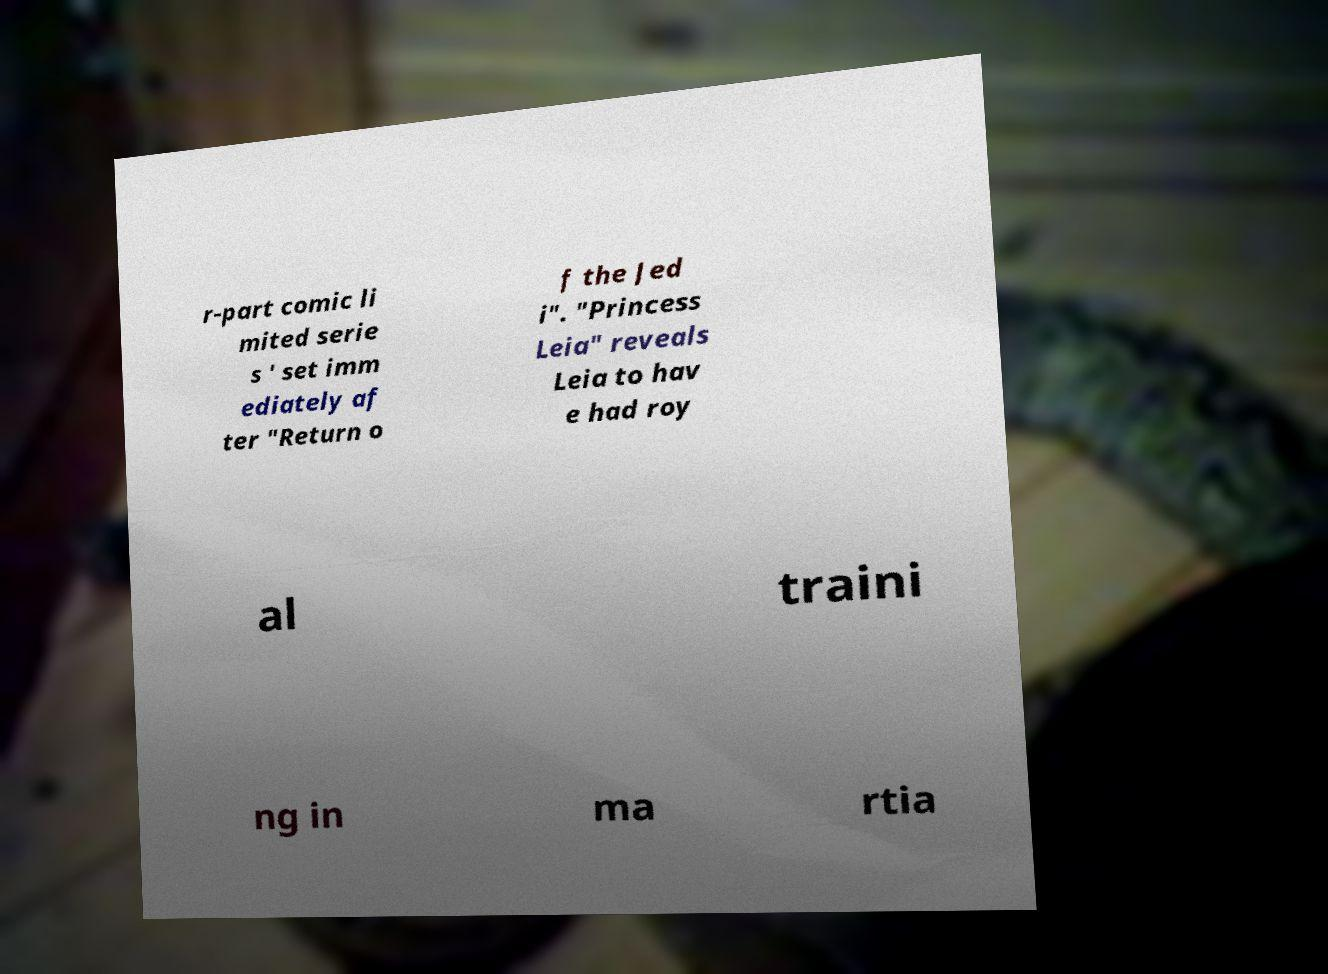I need the written content from this picture converted into text. Can you do that? r-part comic li mited serie s ' set imm ediately af ter "Return o f the Jed i". "Princess Leia" reveals Leia to hav e had roy al traini ng in ma rtia 